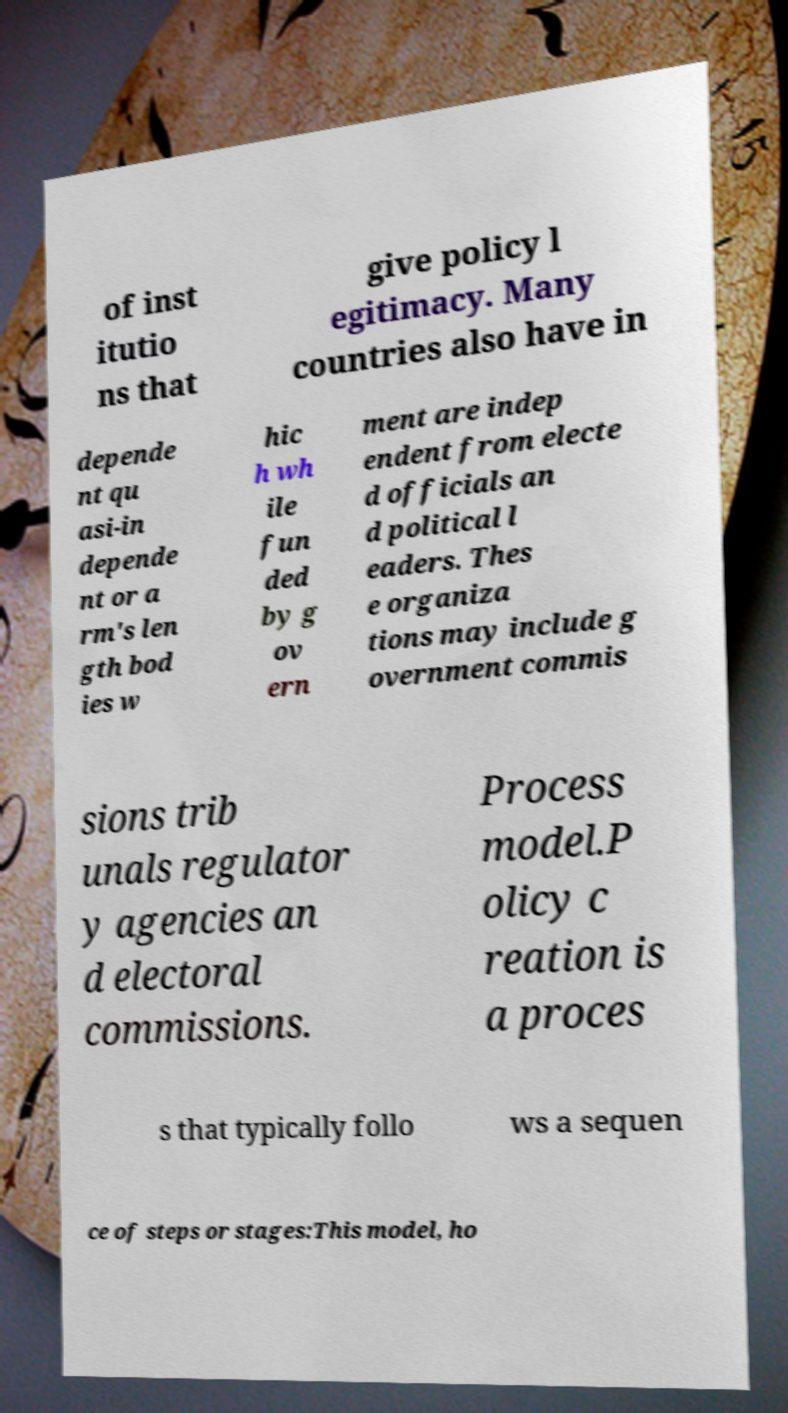There's text embedded in this image that I need extracted. Can you transcribe it verbatim? of inst itutio ns that give policy l egitimacy. Many countries also have in depende nt qu asi-in depende nt or a rm's len gth bod ies w hic h wh ile fun ded by g ov ern ment are indep endent from electe d officials an d political l eaders. Thes e organiza tions may include g overnment commis sions trib unals regulator y agencies an d electoral commissions. Process model.P olicy c reation is a proces s that typically follo ws a sequen ce of steps or stages:This model, ho 